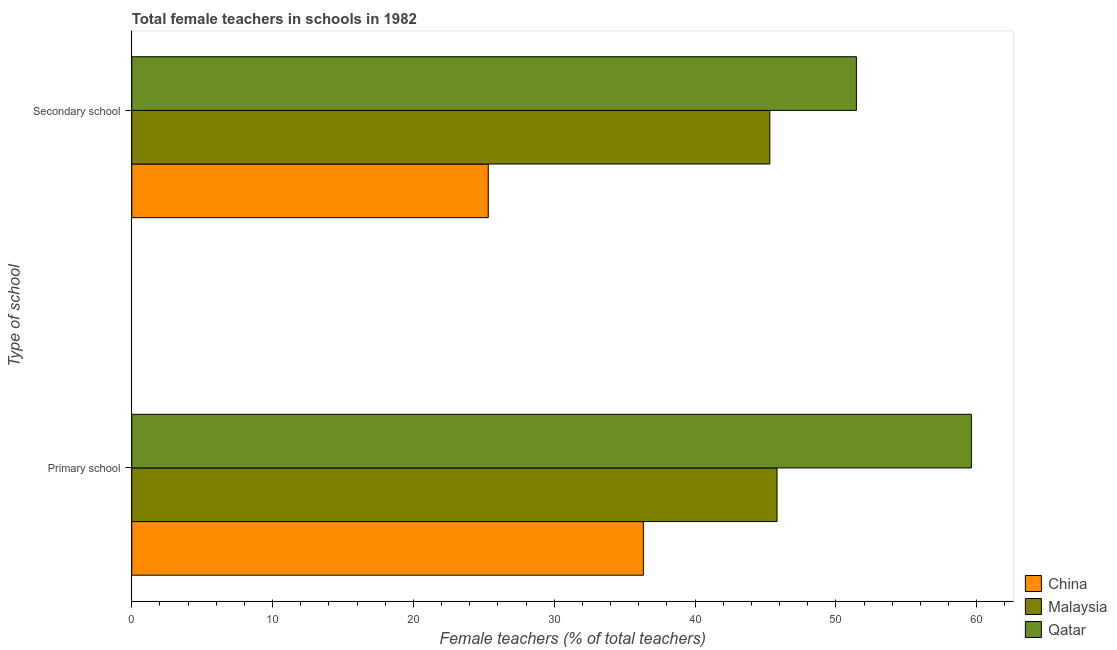How many different coloured bars are there?
Provide a succinct answer. 3. How many bars are there on the 1st tick from the bottom?
Keep it short and to the point. 3. What is the label of the 2nd group of bars from the top?
Give a very brief answer. Primary school. What is the percentage of female teachers in primary schools in Malaysia?
Make the answer very short. 45.82. Across all countries, what is the maximum percentage of female teachers in secondary schools?
Your response must be concise. 51.45. Across all countries, what is the minimum percentage of female teachers in primary schools?
Your answer should be compact. 36.33. In which country was the percentage of female teachers in primary schools maximum?
Make the answer very short. Qatar. In which country was the percentage of female teachers in primary schools minimum?
Offer a terse response. China. What is the total percentage of female teachers in secondary schools in the graph?
Your response must be concise. 122.07. What is the difference between the percentage of female teachers in primary schools in Qatar and that in China?
Provide a short and direct response. 23.29. What is the difference between the percentage of female teachers in primary schools in Malaysia and the percentage of female teachers in secondary schools in China?
Give a very brief answer. 20.51. What is the average percentage of female teachers in secondary schools per country?
Your answer should be very brief. 40.69. What is the difference between the percentage of female teachers in secondary schools and percentage of female teachers in primary schools in China?
Your answer should be very brief. -11.01. What is the ratio of the percentage of female teachers in primary schools in Malaysia to that in China?
Give a very brief answer. 1.26. Is the percentage of female teachers in primary schools in Malaysia less than that in Qatar?
Provide a short and direct response. Yes. What does the 2nd bar from the top in Secondary school represents?
Provide a short and direct response. Malaysia. What does the 3rd bar from the bottom in Secondary school represents?
Make the answer very short. Qatar. How many bars are there?
Your response must be concise. 6. Are all the bars in the graph horizontal?
Make the answer very short. Yes. Where does the legend appear in the graph?
Your answer should be very brief. Bottom right. How are the legend labels stacked?
Offer a terse response. Vertical. What is the title of the graph?
Offer a very short reply. Total female teachers in schools in 1982. What is the label or title of the X-axis?
Provide a succinct answer. Female teachers (% of total teachers). What is the label or title of the Y-axis?
Make the answer very short. Type of school. What is the Female teachers (% of total teachers) of China in Primary school?
Your response must be concise. 36.33. What is the Female teachers (% of total teachers) of Malaysia in Primary school?
Your answer should be compact. 45.82. What is the Female teachers (% of total teachers) in Qatar in Primary school?
Ensure brevity in your answer.  59.62. What is the Female teachers (% of total teachers) in China in Secondary school?
Ensure brevity in your answer.  25.31. What is the Female teachers (% of total teachers) in Malaysia in Secondary school?
Provide a short and direct response. 45.31. What is the Female teachers (% of total teachers) of Qatar in Secondary school?
Ensure brevity in your answer.  51.45. Across all Type of school, what is the maximum Female teachers (% of total teachers) of China?
Keep it short and to the point. 36.33. Across all Type of school, what is the maximum Female teachers (% of total teachers) in Malaysia?
Your answer should be very brief. 45.82. Across all Type of school, what is the maximum Female teachers (% of total teachers) in Qatar?
Your response must be concise. 59.62. Across all Type of school, what is the minimum Female teachers (% of total teachers) in China?
Your response must be concise. 25.31. Across all Type of school, what is the minimum Female teachers (% of total teachers) of Malaysia?
Offer a very short reply. 45.31. Across all Type of school, what is the minimum Female teachers (% of total teachers) of Qatar?
Give a very brief answer. 51.45. What is the total Female teachers (% of total teachers) of China in the graph?
Make the answer very short. 61.64. What is the total Female teachers (% of total teachers) of Malaysia in the graph?
Ensure brevity in your answer.  91.12. What is the total Female teachers (% of total teachers) in Qatar in the graph?
Your answer should be very brief. 111.07. What is the difference between the Female teachers (% of total teachers) in China in Primary school and that in Secondary school?
Your answer should be compact. 11.01. What is the difference between the Female teachers (% of total teachers) of Malaysia in Primary school and that in Secondary school?
Give a very brief answer. 0.51. What is the difference between the Female teachers (% of total teachers) of Qatar in Primary school and that in Secondary school?
Give a very brief answer. 8.16. What is the difference between the Female teachers (% of total teachers) of China in Primary school and the Female teachers (% of total teachers) of Malaysia in Secondary school?
Keep it short and to the point. -8.98. What is the difference between the Female teachers (% of total teachers) in China in Primary school and the Female teachers (% of total teachers) in Qatar in Secondary school?
Keep it short and to the point. -15.13. What is the difference between the Female teachers (% of total teachers) in Malaysia in Primary school and the Female teachers (% of total teachers) in Qatar in Secondary school?
Give a very brief answer. -5.63. What is the average Female teachers (% of total teachers) of China per Type of school?
Make the answer very short. 30.82. What is the average Female teachers (% of total teachers) in Malaysia per Type of school?
Make the answer very short. 45.56. What is the average Female teachers (% of total teachers) in Qatar per Type of school?
Ensure brevity in your answer.  55.54. What is the difference between the Female teachers (% of total teachers) of China and Female teachers (% of total teachers) of Malaysia in Primary school?
Provide a short and direct response. -9.49. What is the difference between the Female teachers (% of total teachers) of China and Female teachers (% of total teachers) of Qatar in Primary school?
Offer a terse response. -23.29. What is the difference between the Female teachers (% of total teachers) in Malaysia and Female teachers (% of total teachers) in Qatar in Primary school?
Your answer should be compact. -13.8. What is the difference between the Female teachers (% of total teachers) in China and Female teachers (% of total teachers) in Malaysia in Secondary school?
Provide a short and direct response. -19.99. What is the difference between the Female teachers (% of total teachers) of China and Female teachers (% of total teachers) of Qatar in Secondary school?
Your answer should be very brief. -26.14. What is the difference between the Female teachers (% of total teachers) in Malaysia and Female teachers (% of total teachers) in Qatar in Secondary school?
Your response must be concise. -6.15. What is the ratio of the Female teachers (% of total teachers) in China in Primary school to that in Secondary school?
Ensure brevity in your answer.  1.44. What is the ratio of the Female teachers (% of total teachers) in Malaysia in Primary school to that in Secondary school?
Give a very brief answer. 1.01. What is the ratio of the Female teachers (% of total teachers) of Qatar in Primary school to that in Secondary school?
Your answer should be very brief. 1.16. What is the difference between the highest and the second highest Female teachers (% of total teachers) in China?
Provide a succinct answer. 11.01. What is the difference between the highest and the second highest Female teachers (% of total teachers) of Malaysia?
Your response must be concise. 0.51. What is the difference between the highest and the second highest Female teachers (% of total teachers) in Qatar?
Provide a short and direct response. 8.16. What is the difference between the highest and the lowest Female teachers (% of total teachers) of China?
Give a very brief answer. 11.01. What is the difference between the highest and the lowest Female teachers (% of total teachers) in Malaysia?
Your answer should be very brief. 0.51. What is the difference between the highest and the lowest Female teachers (% of total teachers) of Qatar?
Make the answer very short. 8.16. 